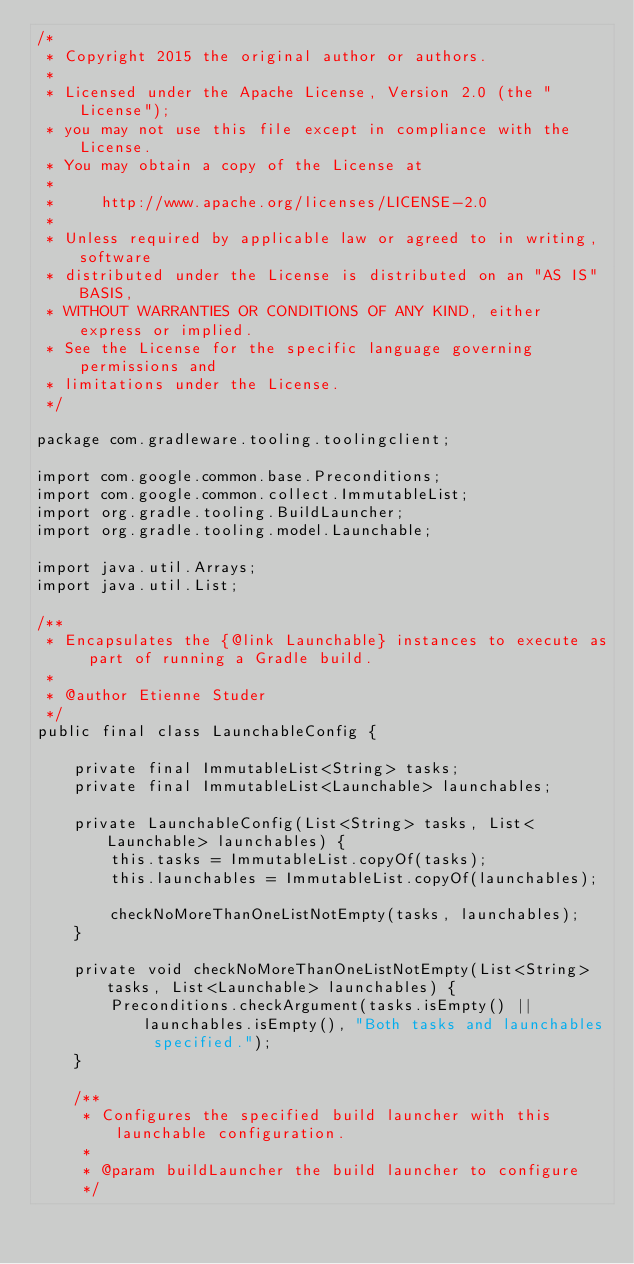Convert code to text. <code><loc_0><loc_0><loc_500><loc_500><_Java_>/*
 * Copyright 2015 the original author or authors.
 *
 * Licensed under the Apache License, Version 2.0 (the "License");
 * you may not use this file except in compliance with the License.
 * You may obtain a copy of the License at
 *
 *     http://www.apache.org/licenses/LICENSE-2.0
 *
 * Unless required by applicable law or agreed to in writing, software
 * distributed under the License is distributed on an "AS IS" BASIS,
 * WITHOUT WARRANTIES OR CONDITIONS OF ANY KIND, either express or implied.
 * See the License for the specific language governing permissions and
 * limitations under the License.
 */

package com.gradleware.tooling.toolingclient;

import com.google.common.base.Preconditions;
import com.google.common.collect.ImmutableList;
import org.gradle.tooling.BuildLauncher;
import org.gradle.tooling.model.Launchable;

import java.util.Arrays;
import java.util.List;

/**
 * Encapsulates the {@link Launchable} instances to execute as part of running a Gradle build.
 *
 * @author Etienne Studer
 */
public final class LaunchableConfig {

    private final ImmutableList<String> tasks;
    private final ImmutableList<Launchable> launchables;

    private LaunchableConfig(List<String> tasks, List<Launchable> launchables) {
        this.tasks = ImmutableList.copyOf(tasks);
        this.launchables = ImmutableList.copyOf(launchables);

        checkNoMoreThanOneListNotEmpty(tasks, launchables);
    }

    private void checkNoMoreThanOneListNotEmpty(List<String> tasks, List<Launchable> launchables) {
        Preconditions.checkArgument(tasks.isEmpty() || launchables.isEmpty(), "Both tasks and launchables specified.");
    }

    /**
     * Configures the specified build launcher with this launchable configuration.
     *
     * @param buildLauncher the build launcher to configure
     */</code> 